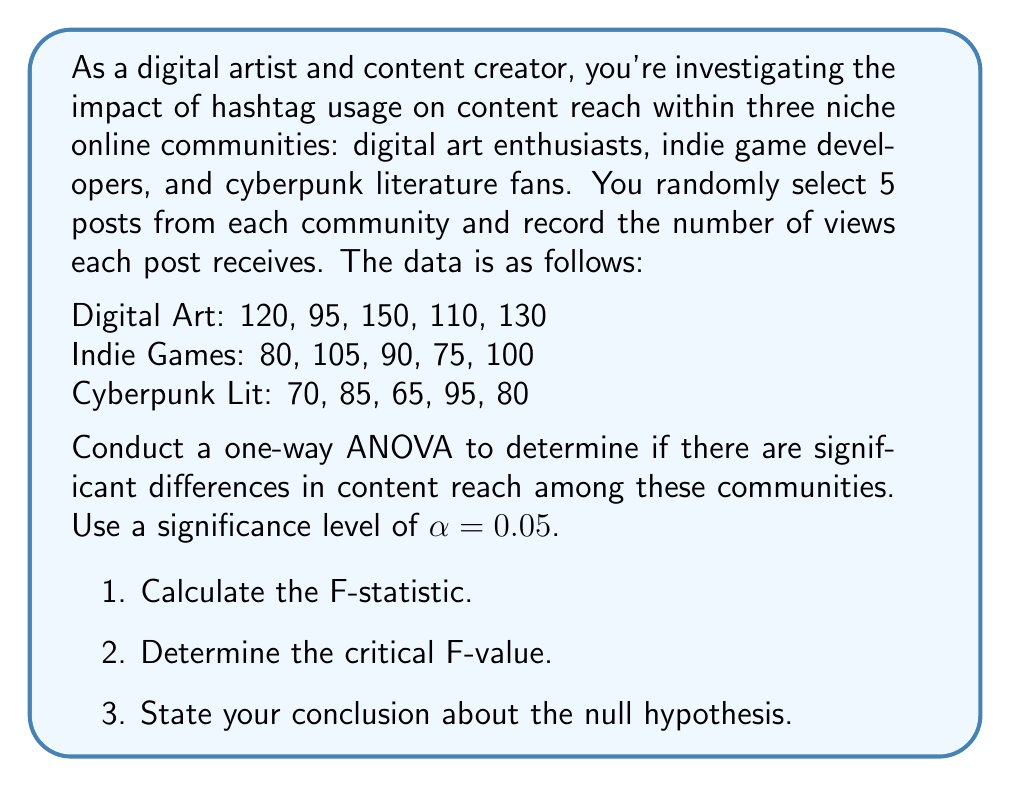What is the answer to this math problem? To conduct a one-way ANOVA, we'll follow these steps:

1. Calculate the sum of squares (SS) for between-groups, within-groups, and total.
2. Calculate the degrees of freedom (df) for between-groups and within-groups.
3. Calculate the mean squares (MS) for between-groups and within-groups.
4. Calculate the F-statistic.
5. Determine the critical F-value and make a decision.

Step 1: Calculate SS

First, we need to calculate the grand mean:
$$\bar{X} = \frac{120 + 95 + 150 + 110 + 130 + 80 + 105 + 90 + 75 + 100 + 70 + 85 + 65 + 95 + 80}{15} = 100$$

Now, let's calculate the group means:
$$\bar{X}_{\text{Digital Art}} = 121$$
$$\bar{X}_{\text{Indie Games}} = 90$$
$$\bar{X}_{\text{Cyberpunk Lit}} = 79$$

SS Between-groups:
$$SS_B = 5[(121 - 100)^2 + (90 - 100)^2 + (79 - 100)^2] = 4410$$

SS Within-groups:
$$SS_W = (120 - 121)^2 + (95 - 121)^2 + ... + (95 - 79)^2 + (80 - 79)^2 = 3850$$

SS Total:
$$SS_T = SS_B + SS_W = 4410 + 3850 = 8260$$

Step 2: Calculate df

$$df_B = k - 1 = 3 - 1 = 2$$
$$df_W = N - k = 15 - 3 = 12$$
$$df_T = N - 1 = 15 - 1 = 14$$

Where k is the number of groups and N is the total number of observations.

Step 3: Calculate MS

$$MS_B = \frac{SS_B}{df_B} = \frac{4410}{2} = 2205$$
$$MS_W = \frac{SS_W}{df_W} = \frac{3850}{12} \approx 320.83$$

Step 4: Calculate F-statistic

$$F = \frac{MS_B}{MS_W} = \frac{2205}{320.83} \approx 6.87$$

Step 5: Determine critical F-value and make decision

For $\alpha = 0.05$, $df_B = 2$, and $df_W = 12$, the critical F-value is approximately 3.89.

Since the calculated F-statistic (6.87) is greater than the critical F-value (3.89), we reject the null hypothesis.
Answer: 1. F-statistic: 6.87
2. Critical F-value: 3.89
3. Conclusion: Reject the null hypothesis. There is significant evidence to suggest that there are differences in content reach among the three niche online communities. 